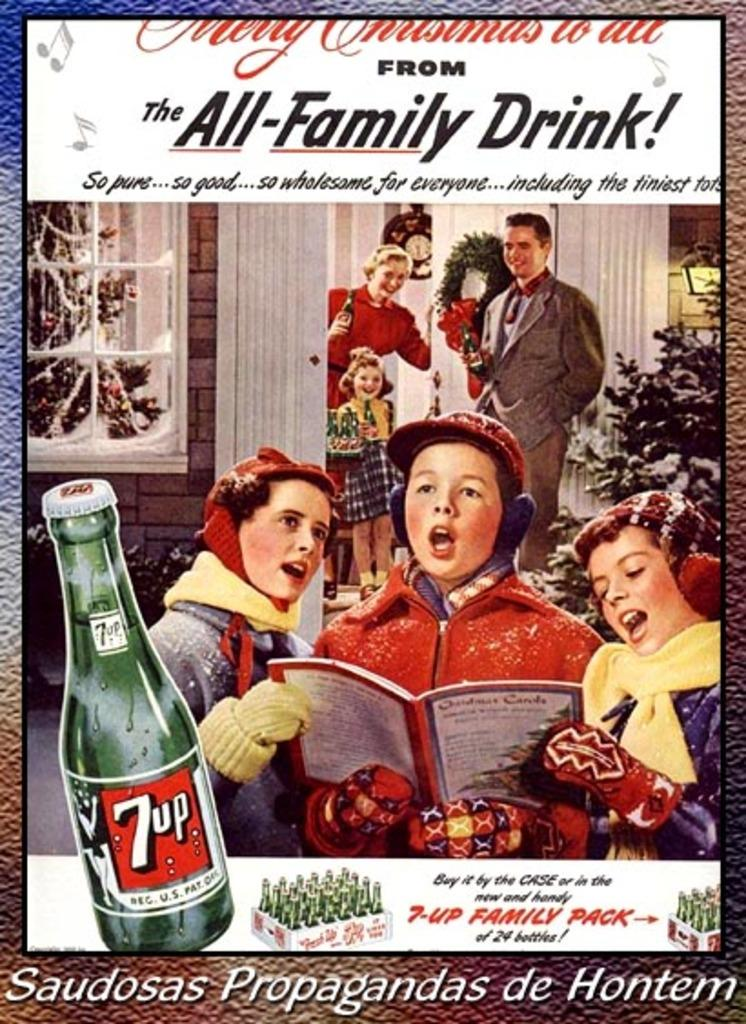What is the main subject in the center of the image? There is a poster in the center of the image. What can be seen on the poster? The poster contains depictions of persons. Are there any words on the poster? Yes, there is text on the poster. How many books are visible on the poster? There are no books depicted on the poster; it features depictions of persons and text. What type of vase is shown in the center of the poster? There is no vase present on the poster; it only contains depictions of persons and text. 